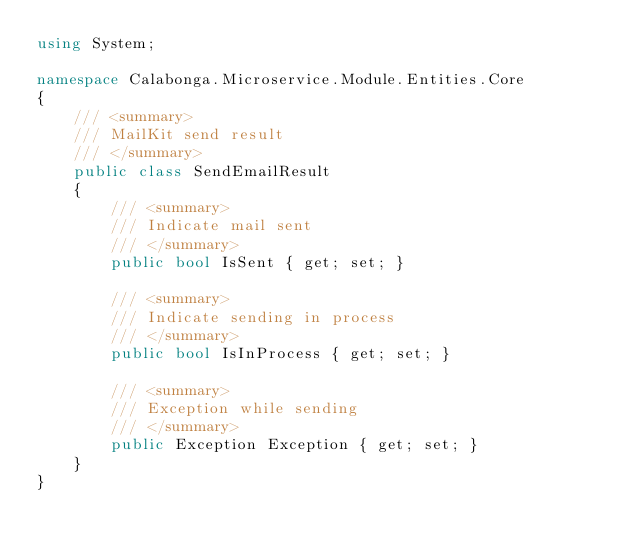<code> <loc_0><loc_0><loc_500><loc_500><_C#_>using System;

namespace Calabonga.Microservice.Module.Entities.Core
{
    /// <summary>
    /// MailKit send result
    /// </summary>
    public class SendEmailResult
    {
        /// <summary>
        /// Indicate mail sent
        /// </summary>
        public bool IsSent { get; set; }

        /// <summary>
        /// Indicate sending in process
        /// </summary>
        public bool IsInProcess { get; set; }

        /// <summary>
        /// Exception while sending
        /// </summary>
        public Exception Exception { get; set; }
    }
}</code> 